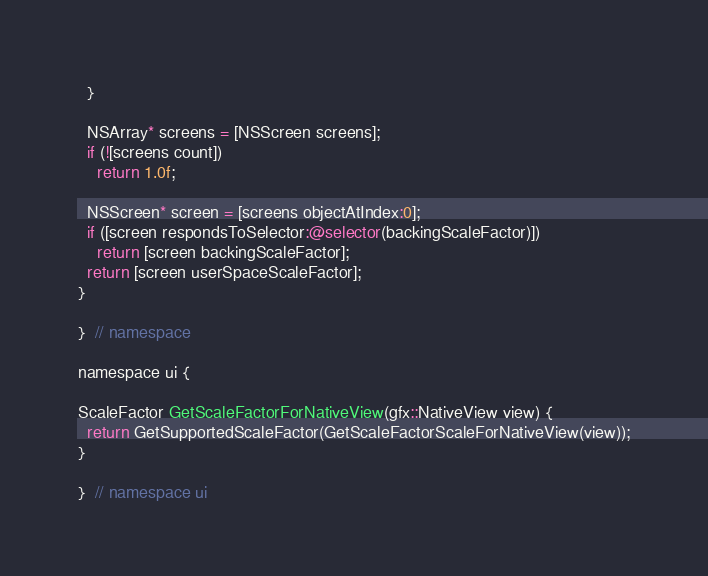Convert code to text. <code><loc_0><loc_0><loc_500><loc_500><_ObjectiveC_>  }

  NSArray* screens = [NSScreen screens];
  if (![screens count])
    return 1.0f;

  NSScreen* screen = [screens objectAtIndex:0];
  if ([screen respondsToSelector:@selector(backingScaleFactor)])
    return [screen backingScaleFactor];
  return [screen userSpaceScaleFactor];
}

}  // namespace

namespace ui {

ScaleFactor GetScaleFactorForNativeView(gfx::NativeView view) {
  return GetSupportedScaleFactor(GetScaleFactorScaleForNativeView(view));
}

}  // namespace ui
</code> 